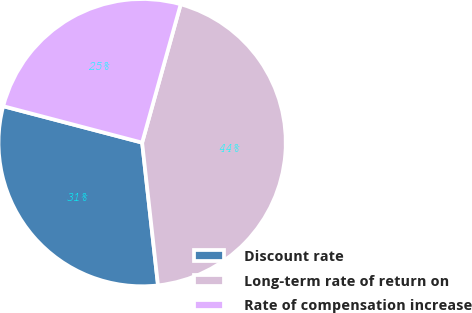Convert chart to OTSL. <chart><loc_0><loc_0><loc_500><loc_500><pie_chart><fcel>Discount rate<fcel>Long-term rate of return on<fcel>Rate of compensation increase<nl><fcel>30.85%<fcel>43.91%<fcel>25.24%<nl></chart> 